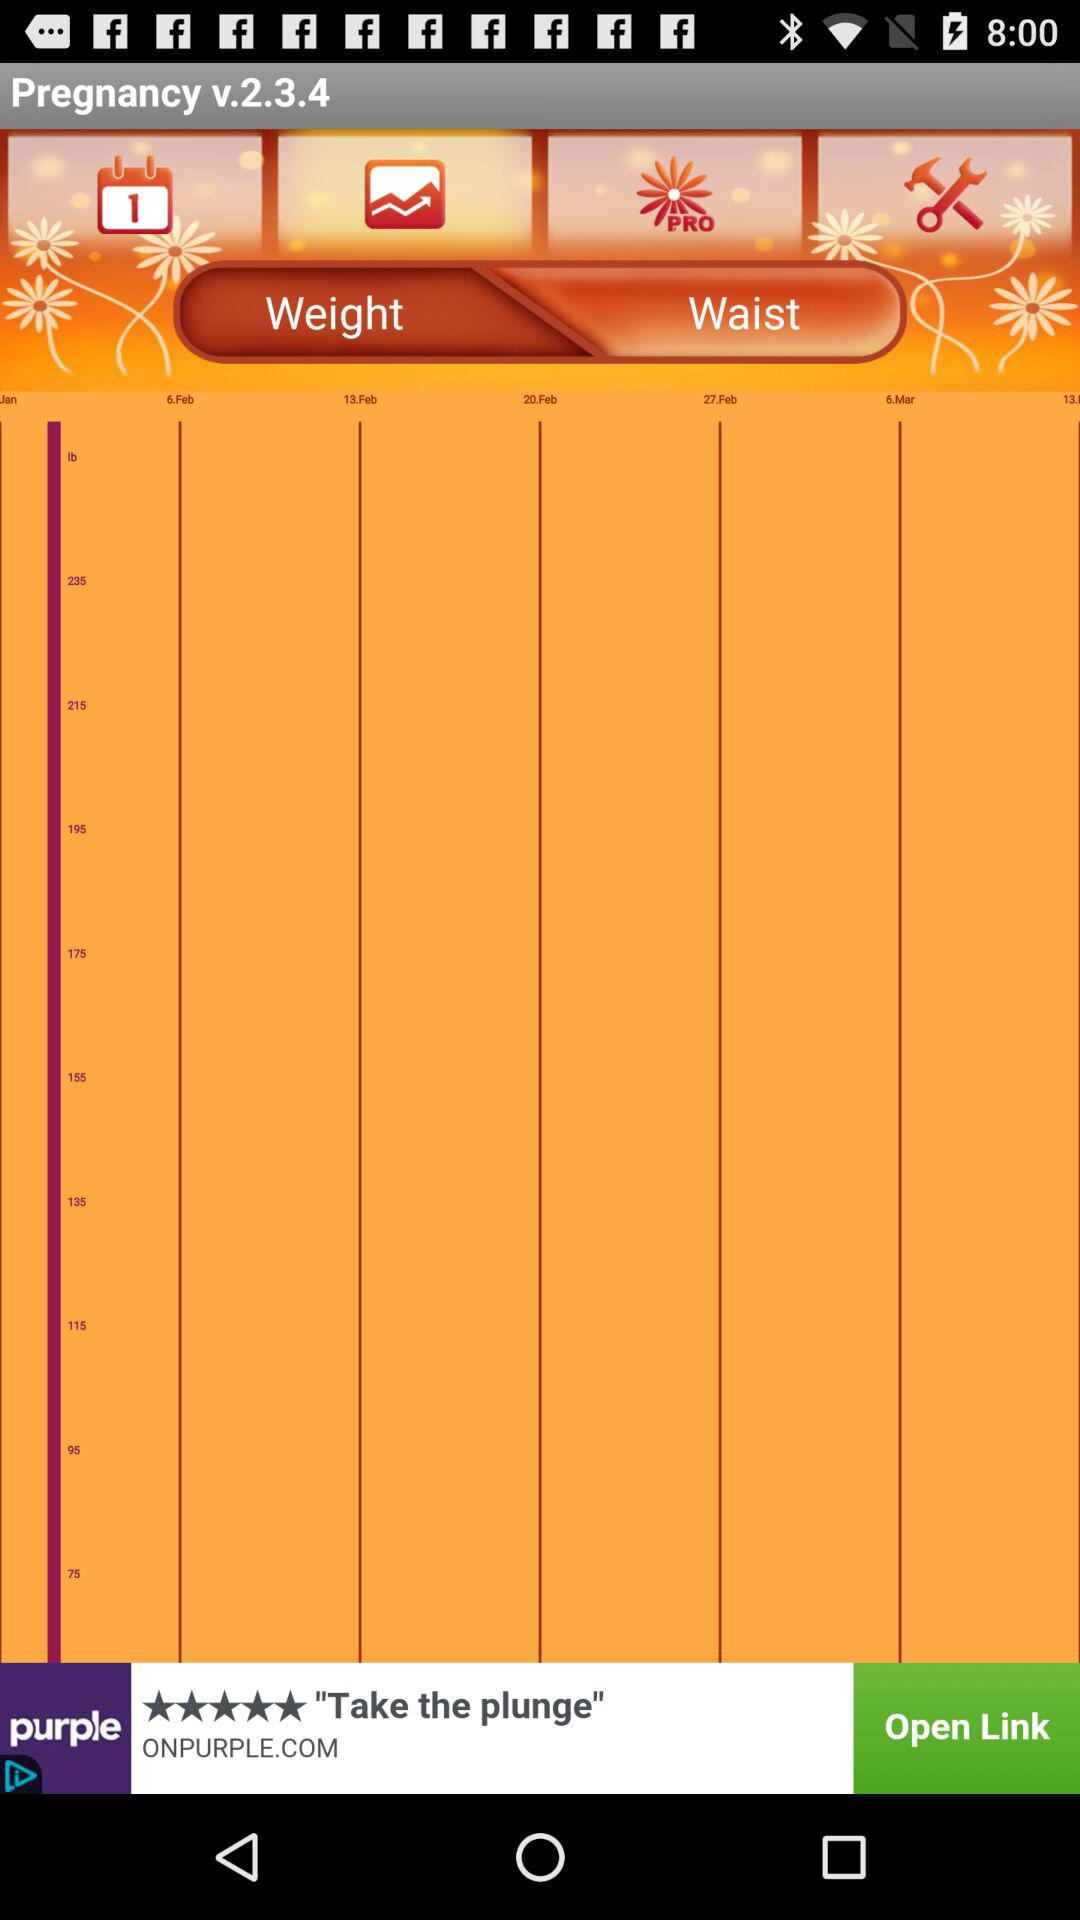What is the version? The version is 2.3.4. 